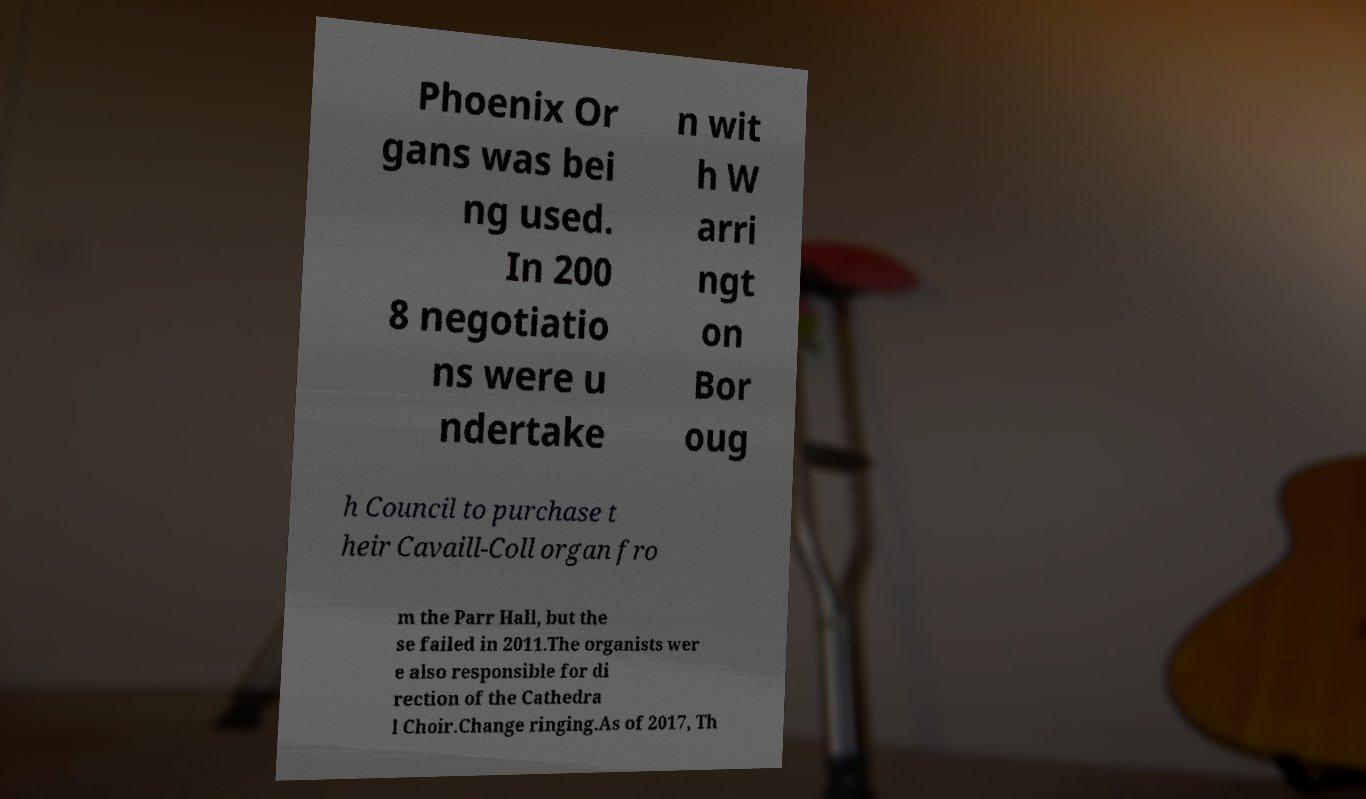Please read and relay the text visible in this image. What does it say? Phoenix Or gans was bei ng used. In 200 8 negotiatio ns were u ndertake n wit h W arri ngt on Bor oug h Council to purchase t heir Cavaill-Coll organ fro m the Parr Hall, but the se failed in 2011.The organists wer e also responsible for di rection of the Cathedra l Choir.Change ringing.As of 2017, Th 